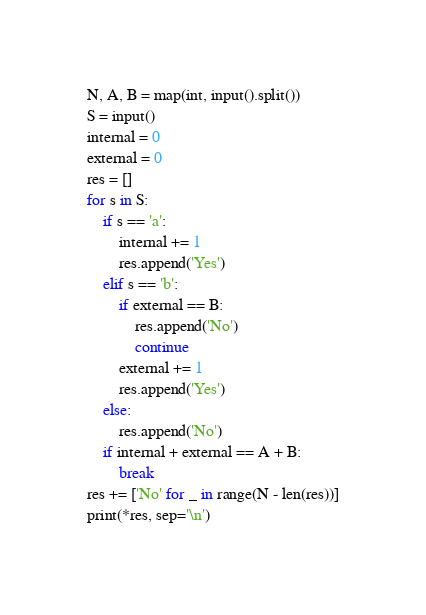Convert code to text. <code><loc_0><loc_0><loc_500><loc_500><_Python_>N, A, B = map(int, input().split())
S = input()
internal = 0
external = 0
res = []
for s in S:
    if s == 'a':
        internal += 1
        res.append('Yes')
    elif s == 'b':
        if external == B:
            res.append('No')
            continue
        external += 1
        res.append('Yes')
    else:
        res.append('No')
    if internal + external == A + B:
        break
res += ['No' for _ in range(N - len(res))]
print(*res, sep='\n')

</code> 